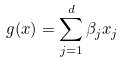<formula> <loc_0><loc_0><loc_500><loc_500>g ( x ) = \sum _ { j = 1 } ^ { d } \beta _ { j } x _ { j }</formula> 